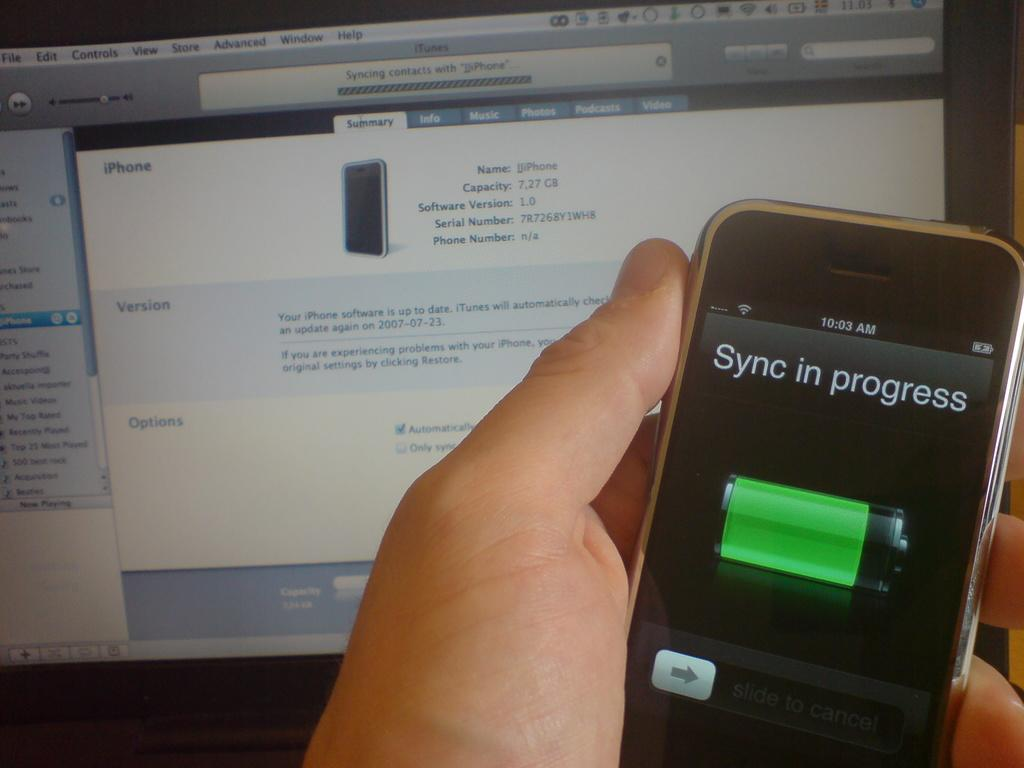Provide a one-sentence caption for the provided image. A smartphone held by a person with a the words Sync in process on the display screen. 